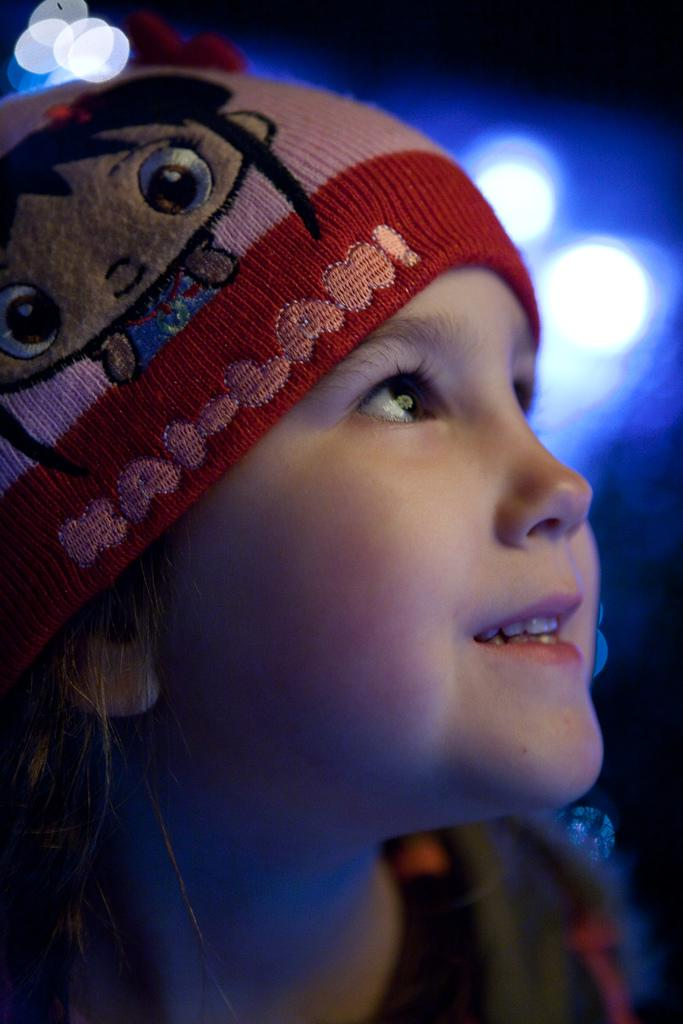Who is the main subject in the image? There is a girl in the image. What is the girl wearing on her head? The girl is wearing a cap. What can be seen in the background of the image? There are lights visible in the background of the image. What type of horn can be heard in the image? There is no horn present in the image, and therefore no sound can be heard. 